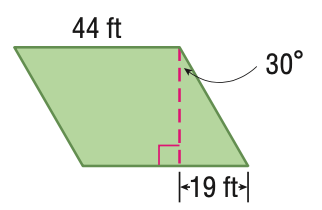Answer the mathemtical geometry problem and directly provide the correct option letter.
Question: Find the area of the parallelogram. Round to the nearest tenth if necessary.
Choices: A: 164 B: 362.0 C: 724.0 D: 1448.0 D 